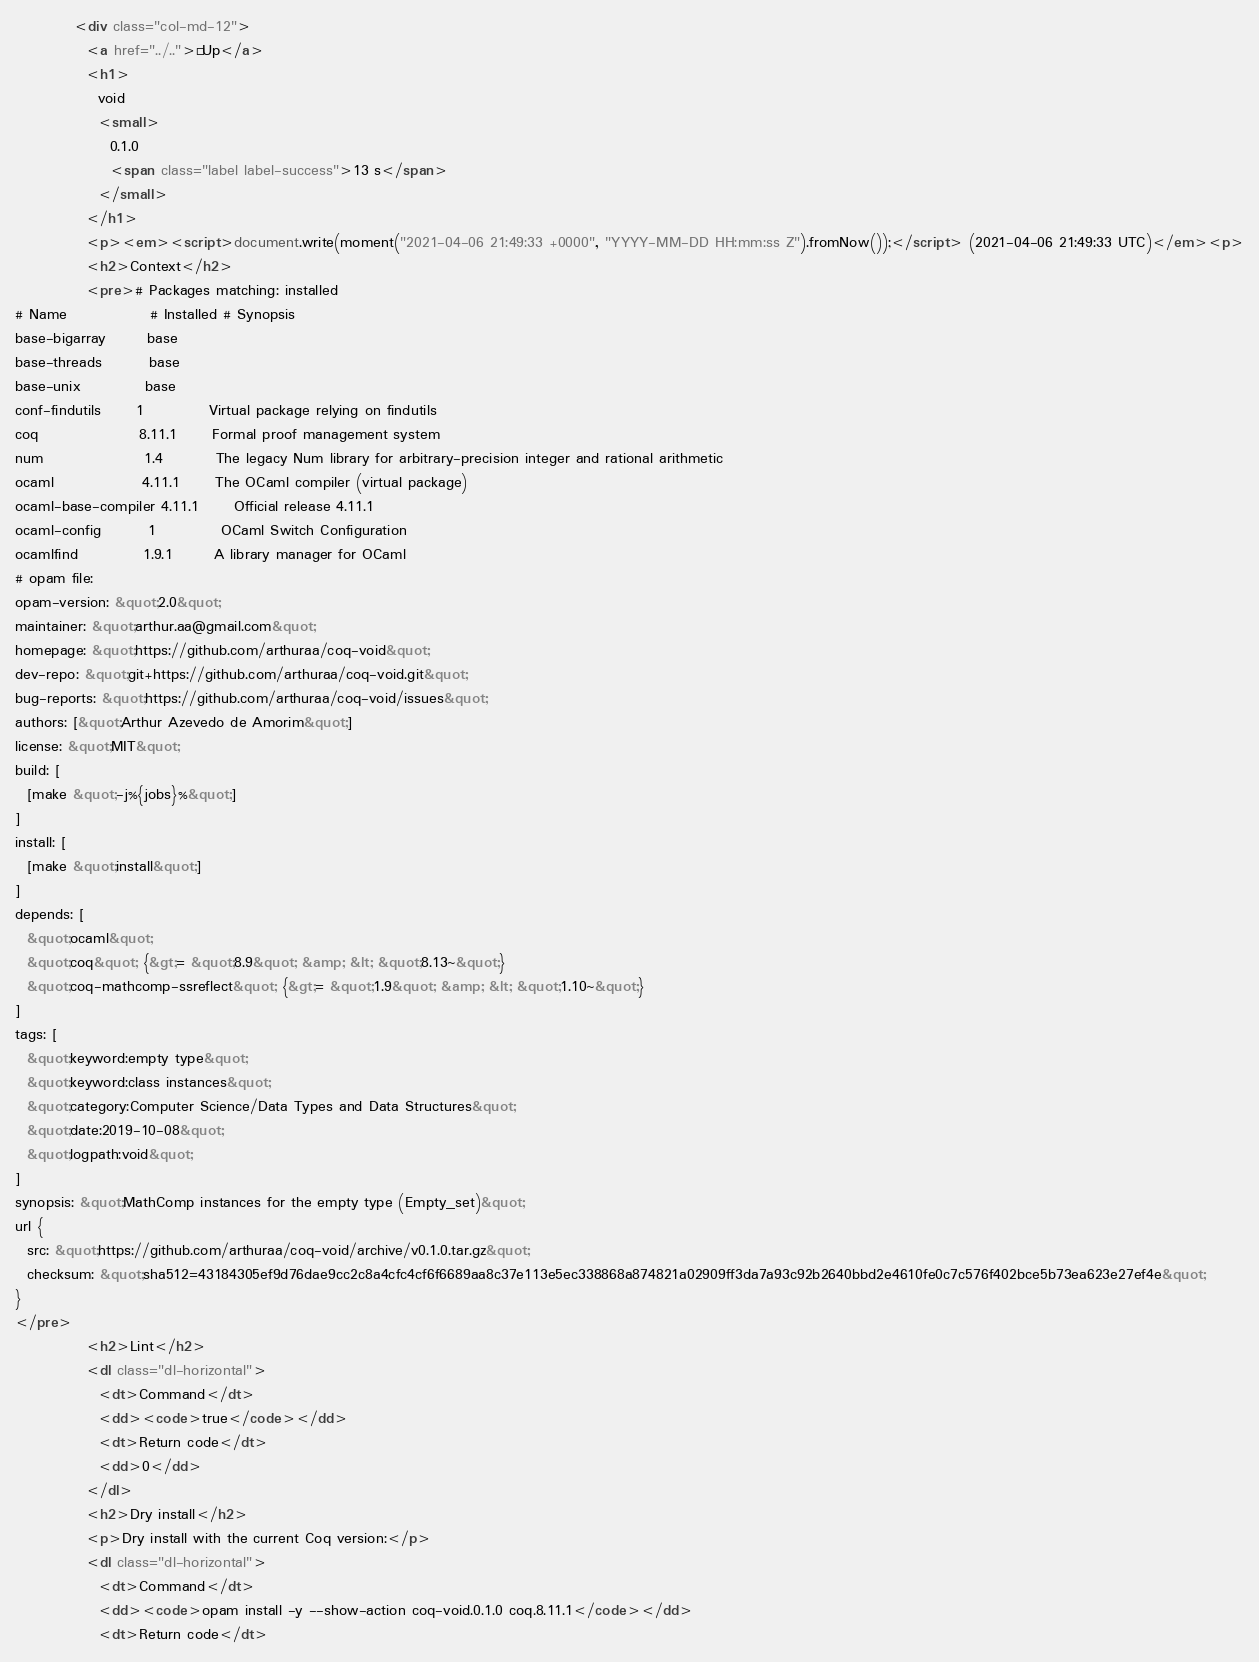Convert code to text. <code><loc_0><loc_0><loc_500><loc_500><_HTML_>          <div class="col-md-12">
            <a href="../..">« Up</a>
            <h1>
              void
              <small>
                0.1.0
                <span class="label label-success">13 s</span>
              </small>
            </h1>
            <p><em><script>document.write(moment("2021-04-06 21:49:33 +0000", "YYYY-MM-DD HH:mm:ss Z").fromNow());</script> (2021-04-06 21:49:33 UTC)</em><p>
            <h2>Context</h2>
            <pre># Packages matching: installed
# Name              # Installed # Synopsis
base-bigarray       base
base-threads        base
base-unix           base
conf-findutils      1           Virtual package relying on findutils
coq                 8.11.1      Formal proof management system
num                 1.4         The legacy Num library for arbitrary-precision integer and rational arithmetic
ocaml               4.11.1      The OCaml compiler (virtual package)
ocaml-base-compiler 4.11.1      Official release 4.11.1
ocaml-config        1           OCaml Switch Configuration
ocamlfind           1.9.1       A library manager for OCaml
# opam file:
opam-version: &quot;2.0&quot;
maintainer: &quot;arthur.aa@gmail.com&quot;
homepage: &quot;https://github.com/arthuraa/coq-void&quot;
dev-repo: &quot;git+https://github.com/arthuraa/coq-void.git&quot;
bug-reports: &quot;https://github.com/arthuraa/coq-void/issues&quot;
authors: [&quot;Arthur Azevedo de Amorim&quot;]
license: &quot;MIT&quot;
build: [
  [make &quot;-j%{jobs}%&quot;]
]
install: [
  [make &quot;install&quot;]
]
depends: [
  &quot;ocaml&quot;
  &quot;coq&quot; {&gt;= &quot;8.9&quot; &amp; &lt; &quot;8.13~&quot;}
  &quot;coq-mathcomp-ssreflect&quot; {&gt;= &quot;1.9&quot; &amp; &lt; &quot;1.10~&quot;}
]
tags: [
  &quot;keyword:empty type&quot;
  &quot;keyword:class instances&quot;
  &quot;category:Computer Science/Data Types and Data Structures&quot;
  &quot;date:2019-10-08&quot;
  &quot;logpath:void&quot;
]
synopsis: &quot;MathComp instances for the empty type (Empty_set)&quot;
url {
  src: &quot;https://github.com/arthuraa/coq-void/archive/v0.1.0.tar.gz&quot;
  checksum: &quot;sha512=43184305ef9d76dae9cc2c8a4cfc4cf6f6689aa8c37e113e5ec338868a874821a02909ff3da7a93c92b2640bbd2e4610fe0c7c576f402bce5b73ea623e27ef4e&quot;
}
</pre>
            <h2>Lint</h2>
            <dl class="dl-horizontal">
              <dt>Command</dt>
              <dd><code>true</code></dd>
              <dt>Return code</dt>
              <dd>0</dd>
            </dl>
            <h2>Dry install</h2>
            <p>Dry install with the current Coq version:</p>
            <dl class="dl-horizontal">
              <dt>Command</dt>
              <dd><code>opam install -y --show-action coq-void.0.1.0 coq.8.11.1</code></dd>
              <dt>Return code</dt></code> 